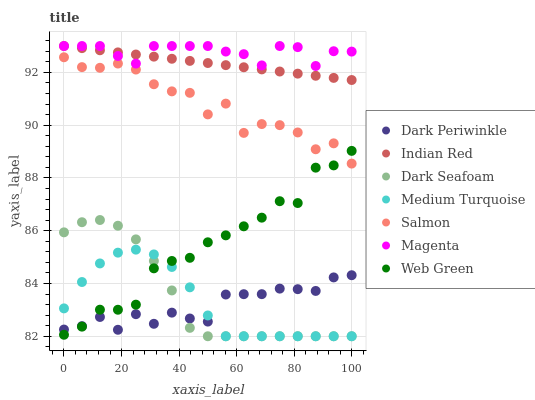Does Dark Periwinkle have the minimum area under the curve?
Answer yes or no. Yes. Does Magenta have the maximum area under the curve?
Answer yes or no. Yes. Does Salmon have the minimum area under the curve?
Answer yes or no. No. Does Salmon have the maximum area under the curve?
Answer yes or no. No. Is Indian Red the smoothest?
Answer yes or no. Yes. Is Salmon the roughest?
Answer yes or no. Yes. Is Web Green the smoothest?
Answer yes or no. No. Is Web Green the roughest?
Answer yes or no. No. Does Medium Turquoise have the lowest value?
Answer yes or no. Yes. Does Salmon have the lowest value?
Answer yes or no. No. Does Magenta have the highest value?
Answer yes or no. Yes. Does Salmon have the highest value?
Answer yes or no. No. Is Web Green less than Magenta?
Answer yes or no. Yes. Is Indian Red greater than Medium Turquoise?
Answer yes or no. Yes. Does Medium Turquoise intersect Dark Periwinkle?
Answer yes or no. Yes. Is Medium Turquoise less than Dark Periwinkle?
Answer yes or no. No. Is Medium Turquoise greater than Dark Periwinkle?
Answer yes or no. No. Does Web Green intersect Magenta?
Answer yes or no. No. 